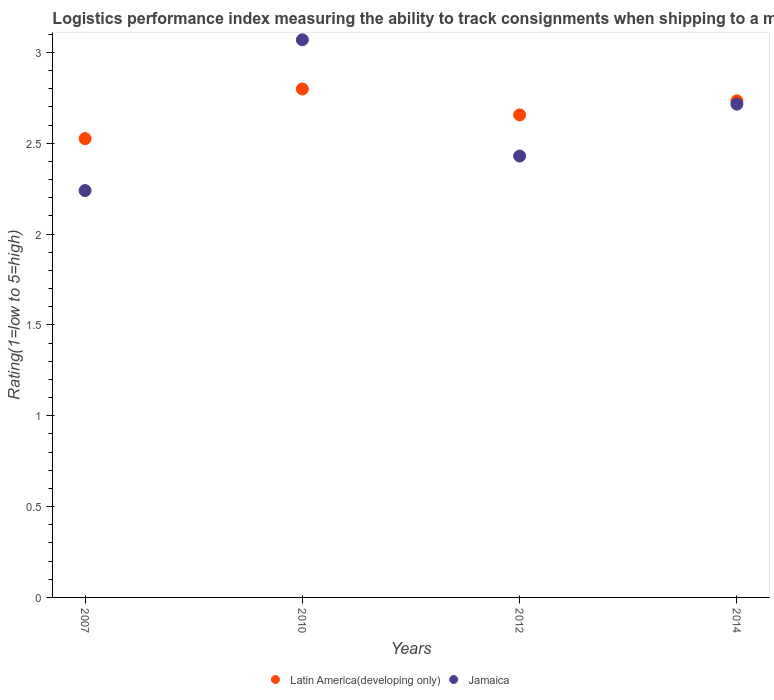How many different coloured dotlines are there?
Keep it short and to the point. 2. What is the Logistic performance index in Jamaica in 2012?
Your answer should be compact. 2.43. Across all years, what is the maximum Logistic performance index in Jamaica?
Your answer should be very brief. 3.07. Across all years, what is the minimum Logistic performance index in Latin America(developing only)?
Provide a succinct answer. 2.53. In which year was the Logistic performance index in Latin America(developing only) minimum?
Your response must be concise. 2007. What is the total Logistic performance index in Latin America(developing only) in the graph?
Give a very brief answer. 10.72. What is the difference between the Logistic performance index in Latin America(developing only) in 2007 and that in 2012?
Provide a succinct answer. -0.13. What is the difference between the Logistic performance index in Jamaica in 2010 and the Logistic performance index in Latin America(developing only) in 2012?
Provide a succinct answer. 0.41. What is the average Logistic performance index in Jamaica per year?
Your answer should be very brief. 2.61. In the year 2012, what is the difference between the Logistic performance index in Latin America(developing only) and Logistic performance index in Jamaica?
Keep it short and to the point. 0.23. What is the ratio of the Logistic performance index in Latin America(developing only) in 2007 to that in 2014?
Make the answer very short. 0.92. Is the Logistic performance index in Jamaica in 2007 less than that in 2010?
Offer a very short reply. Yes. What is the difference between the highest and the second highest Logistic performance index in Jamaica?
Make the answer very short. 0.35. What is the difference between the highest and the lowest Logistic performance index in Jamaica?
Your answer should be compact. 0.83. Is the sum of the Logistic performance index in Latin America(developing only) in 2012 and 2014 greater than the maximum Logistic performance index in Jamaica across all years?
Offer a terse response. Yes. How many years are there in the graph?
Your response must be concise. 4. Are the values on the major ticks of Y-axis written in scientific E-notation?
Make the answer very short. No. Where does the legend appear in the graph?
Keep it short and to the point. Bottom center. How many legend labels are there?
Make the answer very short. 2. How are the legend labels stacked?
Provide a short and direct response. Horizontal. What is the title of the graph?
Your answer should be very brief. Logistics performance index measuring the ability to track consignments when shipping to a market. What is the label or title of the Y-axis?
Make the answer very short. Rating(1=low to 5=high). What is the Rating(1=low to 5=high) in Latin America(developing only) in 2007?
Your response must be concise. 2.53. What is the Rating(1=low to 5=high) in Jamaica in 2007?
Provide a short and direct response. 2.24. What is the Rating(1=low to 5=high) of Latin America(developing only) in 2010?
Offer a terse response. 2.8. What is the Rating(1=low to 5=high) of Jamaica in 2010?
Your answer should be compact. 3.07. What is the Rating(1=low to 5=high) in Latin America(developing only) in 2012?
Give a very brief answer. 2.66. What is the Rating(1=low to 5=high) of Jamaica in 2012?
Your answer should be compact. 2.43. What is the Rating(1=low to 5=high) of Latin America(developing only) in 2014?
Your answer should be compact. 2.73. What is the Rating(1=low to 5=high) of Jamaica in 2014?
Make the answer very short. 2.72. Across all years, what is the maximum Rating(1=low to 5=high) in Latin America(developing only)?
Your response must be concise. 2.8. Across all years, what is the maximum Rating(1=low to 5=high) in Jamaica?
Your answer should be compact. 3.07. Across all years, what is the minimum Rating(1=low to 5=high) of Latin America(developing only)?
Your answer should be compact. 2.53. Across all years, what is the minimum Rating(1=low to 5=high) of Jamaica?
Ensure brevity in your answer.  2.24. What is the total Rating(1=low to 5=high) of Latin America(developing only) in the graph?
Give a very brief answer. 10.72. What is the total Rating(1=low to 5=high) in Jamaica in the graph?
Provide a short and direct response. 10.46. What is the difference between the Rating(1=low to 5=high) of Latin America(developing only) in 2007 and that in 2010?
Keep it short and to the point. -0.27. What is the difference between the Rating(1=low to 5=high) of Jamaica in 2007 and that in 2010?
Provide a succinct answer. -0.83. What is the difference between the Rating(1=low to 5=high) of Latin America(developing only) in 2007 and that in 2012?
Your response must be concise. -0.13. What is the difference between the Rating(1=low to 5=high) in Jamaica in 2007 and that in 2012?
Offer a terse response. -0.19. What is the difference between the Rating(1=low to 5=high) of Latin America(developing only) in 2007 and that in 2014?
Your answer should be compact. -0.21. What is the difference between the Rating(1=low to 5=high) in Jamaica in 2007 and that in 2014?
Your response must be concise. -0.48. What is the difference between the Rating(1=low to 5=high) of Latin America(developing only) in 2010 and that in 2012?
Ensure brevity in your answer.  0.14. What is the difference between the Rating(1=low to 5=high) in Jamaica in 2010 and that in 2012?
Offer a terse response. 0.64. What is the difference between the Rating(1=low to 5=high) in Latin America(developing only) in 2010 and that in 2014?
Offer a terse response. 0.07. What is the difference between the Rating(1=low to 5=high) in Jamaica in 2010 and that in 2014?
Your response must be concise. 0.35. What is the difference between the Rating(1=low to 5=high) of Latin America(developing only) in 2012 and that in 2014?
Your answer should be compact. -0.08. What is the difference between the Rating(1=low to 5=high) in Jamaica in 2012 and that in 2014?
Give a very brief answer. -0.29. What is the difference between the Rating(1=low to 5=high) of Latin America(developing only) in 2007 and the Rating(1=low to 5=high) of Jamaica in 2010?
Keep it short and to the point. -0.54. What is the difference between the Rating(1=low to 5=high) in Latin America(developing only) in 2007 and the Rating(1=low to 5=high) in Jamaica in 2012?
Provide a short and direct response. 0.1. What is the difference between the Rating(1=low to 5=high) of Latin America(developing only) in 2007 and the Rating(1=low to 5=high) of Jamaica in 2014?
Make the answer very short. -0.19. What is the difference between the Rating(1=low to 5=high) in Latin America(developing only) in 2010 and the Rating(1=low to 5=high) in Jamaica in 2012?
Your answer should be compact. 0.37. What is the difference between the Rating(1=low to 5=high) in Latin America(developing only) in 2010 and the Rating(1=low to 5=high) in Jamaica in 2014?
Ensure brevity in your answer.  0.08. What is the difference between the Rating(1=low to 5=high) of Latin America(developing only) in 2012 and the Rating(1=low to 5=high) of Jamaica in 2014?
Give a very brief answer. -0.06. What is the average Rating(1=low to 5=high) in Latin America(developing only) per year?
Offer a very short reply. 2.68. What is the average Rating(1=low to 5=high) in Jamaica per year?
Make the answer very short. 2.61. In the year 2007, what is the difference between the Rating(1=low to 5=high) in Latin America(developing only) and Rating(1=low to 5=high) in Jamaica?
Your answer should be compact. 0.29. In the year 2010, what is the difference between the Rating(1=low to 5=high) in Latin America(developing only) and Rating(1=low to 5=high) in Jamaica?
Offer a very short reply. -0.27. In the year 2012, what is the difference between the Rating(1=low to 5=high) in Latin America(developing only) and Rating(1=low to 5=high) in Jamaica?
Your response must be concise. 0.23. In the year 2014, what is the difference between the Rating(1=low to 5=high) in Latin America(developing only) and Rating(1=low to 5=high) in Jamaica?
Keep it short and to the point. 0.02. What is the ratio of the Rating(1=low to 5=high) in Latin America(developing only) in 2007 to that in 2010?
Ensure brevity in your answer.  0.9. What is the ratio of the Rating(1=low to 5=high) in Jamaica in 2007 to that in 2010?
Make the answer very short. 0.73. What is the ratio of the Rating(1=low to 5=high) of Latin America(developing only) in 2007 to that in 2012?
Provide a short and direct response. 0.95. What is the ratio of the Rating(1=low to 5=high) of Jamaica in 2007 to that in 2012?
Offer a terse response. 0.92. What is the ratio of the Rating(1=low to 5=high) in Latin America(developing only) in 2007 to that in 2014?
Offer a very short reply. 0.92. What is the ratio of the Rating(1=low to 5=high) of Jamaica in 2007 to that in 2014?
Give a very brief answer. 0.82. What is the ratio of the Rating(1=low to 5=high) of Latin America(developing only) in 2010 to that in 2012?
Your answer should be very brief. 1.05. What is the ratio of the Rating(1=low to 5=high) in Jamaica in 2010 to that in 2012?
Make the answer very short. 1.26. What is the ratio of the Rating(1=low to 5=high) in Latin America(developing only) in 2010 to that in 2014?
Your answer should be compact. 1.02. What is the ratio of the Rating(1=low to 5=high) of Jamaica in 2010 to that in 2014?
Provide a short and direct response. 1.13. What is the ratio of the Rating(1=low to 5=high) in Latin America(developing only) in 2012 to that in 2014?
Offer a terse response. 0.97. What is the ratio of the Rating(1=low to 5=high) in Jamaica in 2012 to that in 2014?
Ensure brevity in your answer.  0.89. What is the difference between the highest and the second highest Rating(1=low to 5=high) of Latin America(developing only)?
Your answer should be compact. 0.07. What is the difference between the highest and the second highest Rating(1=low to 5=high) of Jamaica?
Offer a terse response. 0.35. What is the difference between the highest and the lowest Rating(1=low to 5=high) of Latin America(developing only)?
Provide a succinct answer. 0.27. What is the difference between the highest and the lowest Rating(1=low to 5=high) of Jamaica?
Provide a short and direct response. 0.83. 